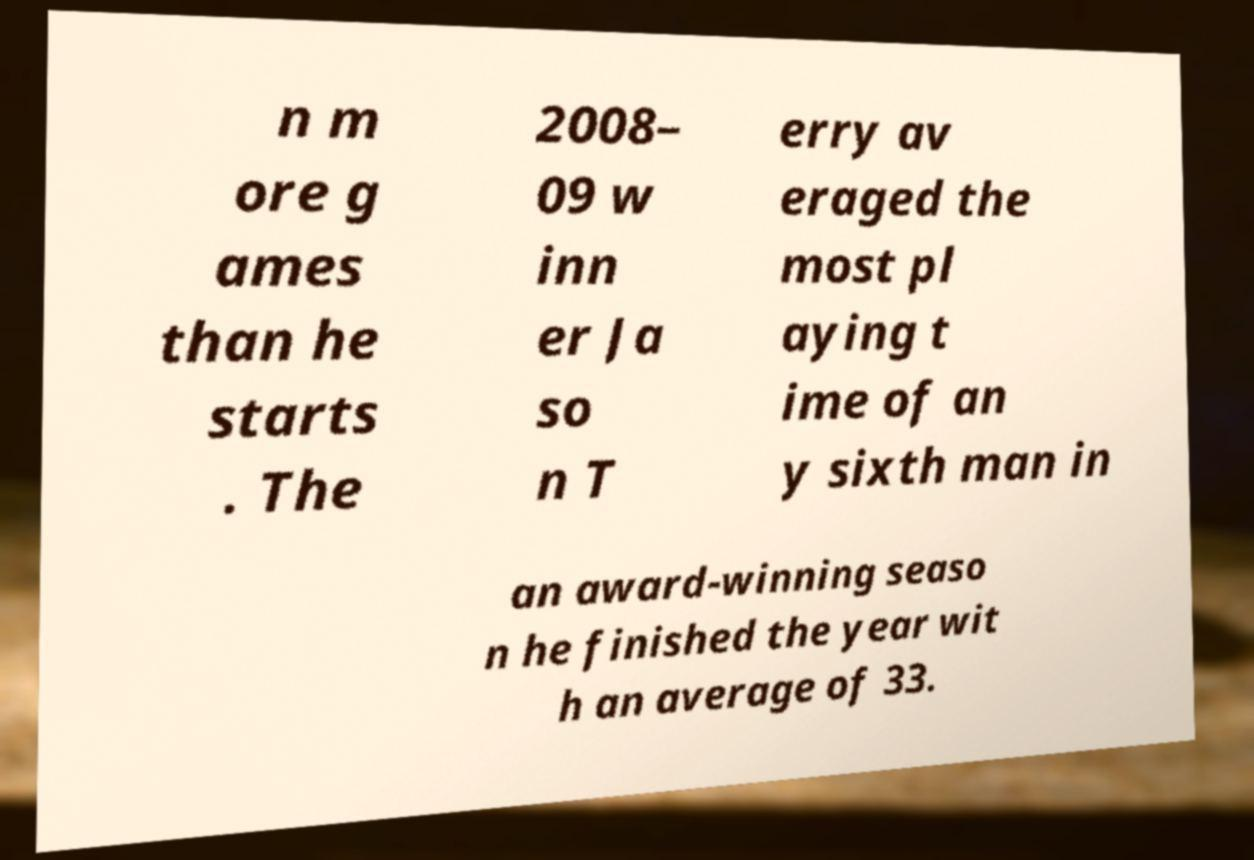I need the written content from this picture converted into text. Can you do that? n m ore g ames than he starts . The 2008– 09 w inn er Ja so n T erry av eraged the most pl aying t ime of an y sixth man in an award-winning seaso n he finished the year wit h an average of 33. 